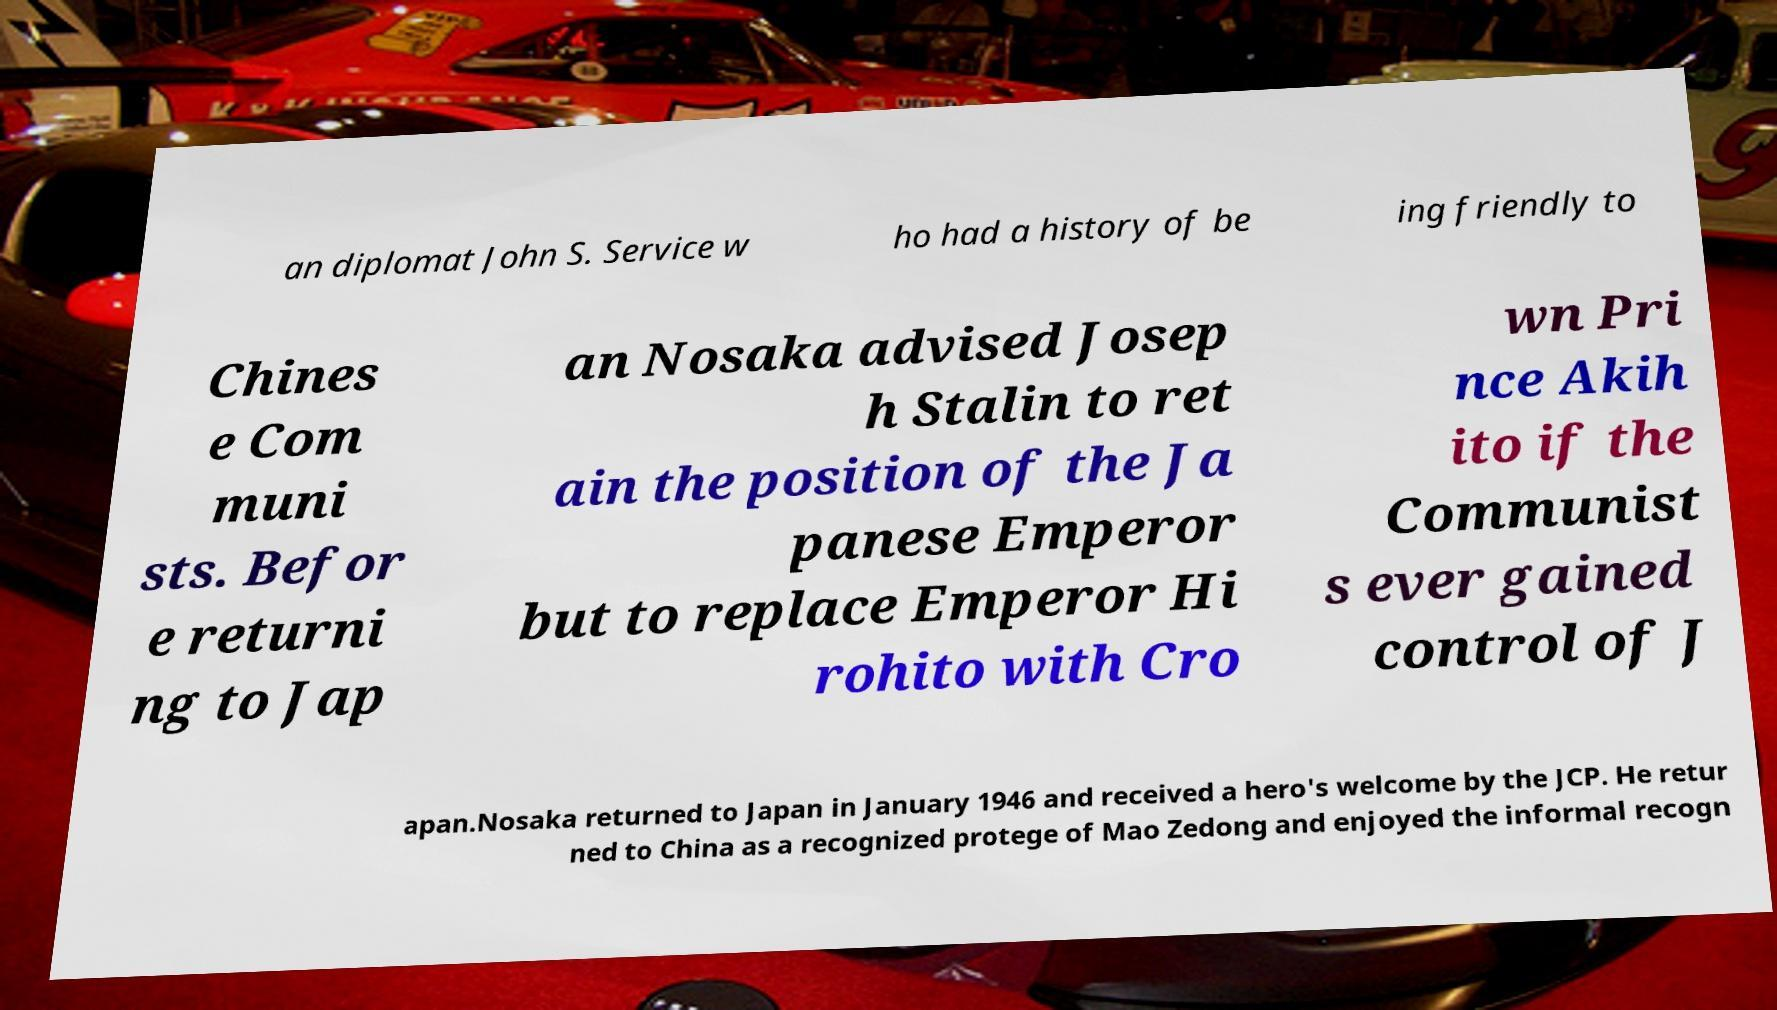Please identify and transcribe the text found in this image. an diplomat John S. Service w ho had a history of be ing friendly to Chines e Com muni sts. Befor e returni ng to Jap an Nosaka advised Josep h Stalin to ret ain the position of the Ja panese Emperor but to replace Emperor Hi rohito with Cro wn Pri nce Akih ito if the Communist s ever gained control of J apan.Nosaka returned to Japan in January 1946 and received a hero's welcome by the JCP. He retur ned to China as a recognized protege of Mao Zedong and enjoyed the informal recogn 